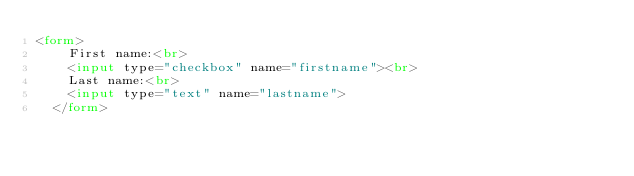<code> <loc_0><loc_0><loc_500><loc_500><_HTML_><form>
    First name:<br>
    <input type="checkbox" name="firstname"><br>
    Last name:<br>
    <input type="text" name="lastname">
  </form></code> 